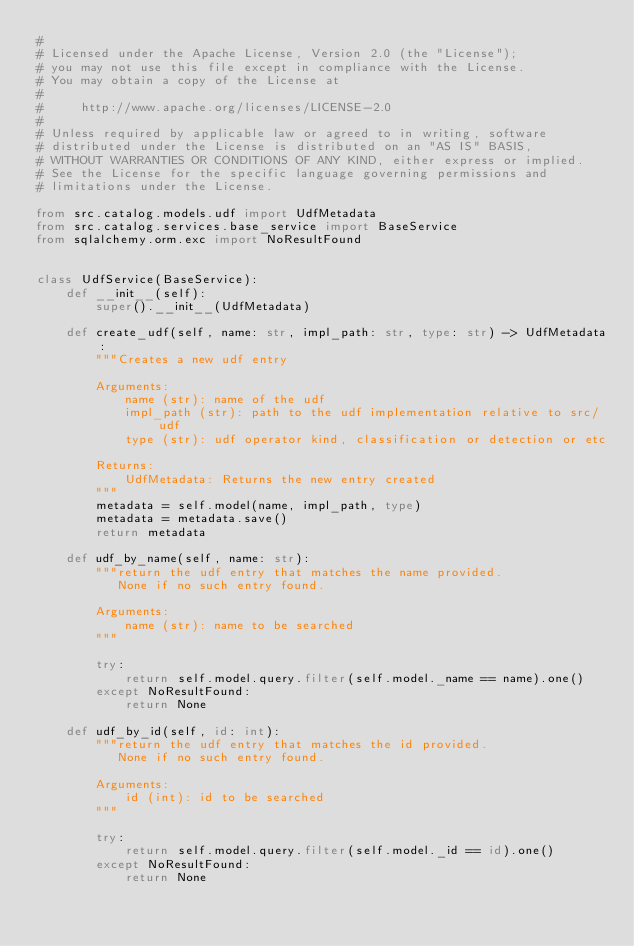Convert code to text. <code><loc_0><loc_0><loc_500><loc_500><_Python_>#
# Licensed under the Apache License, Version 2.0 (the "License");
# you may not use this file except in compliance with the License.
# You may obtain a copy of the License at
#
#     http://www.apache.org/licenses/LICENSE-2.0
#
# Unless required by applicable law or agreed to in writing, software
# distributed under the License is distributed on an "AS IS" BASIS,
# WITHOUT WARRANTIES OR CONDITIONS OF ANY KIND, either express or implied.
# See the License for the specific language governing permissions and
# limitations under the License.

from src.catalog.models.udf import UdfMetadata
from src.catalog.services.base_service import BaseService
from sqlalchemy.orm.exc import NoResultFound


class UdfService(BaseService):
    def __init__(self):
        super().__init__(UdfMetadata)

    def create_udf(self, name: str, impl_path: str, type: str) -> UdfMetadata:
        """Creates a new udf entry

        Arguments:
            name (str): name of the udf
            impl_path (str): path to the udf implementation relative to src/udf
            type (str): udf operator kind, classification or detection or etc

        Returns:
            UdfMetadata: Returns the new entry created
        """
        metadata = self.model(name, impl_path, type)
        metadata = metadata.save()
        return metadata

    def udf_by_name(self, name: str):
        """return the udf entry that matches the name provided.
           None if no such entry found.

        Arguments:
            name (str): name to be searched
        """

        try:
            return self.model.query.filter(self.model._name == name).one()
        except NoResultFound:
            return None

    def udf_by_id(self, id: int):
        """return the udf entry that matches the id provided.
           None if no such entry found.

        Arguments:
            id (int): id to be searched
        """

        try:
            return self.model.query.filter(self.model._id == id).one()
        except NoResultFound:
            return None
</code> 